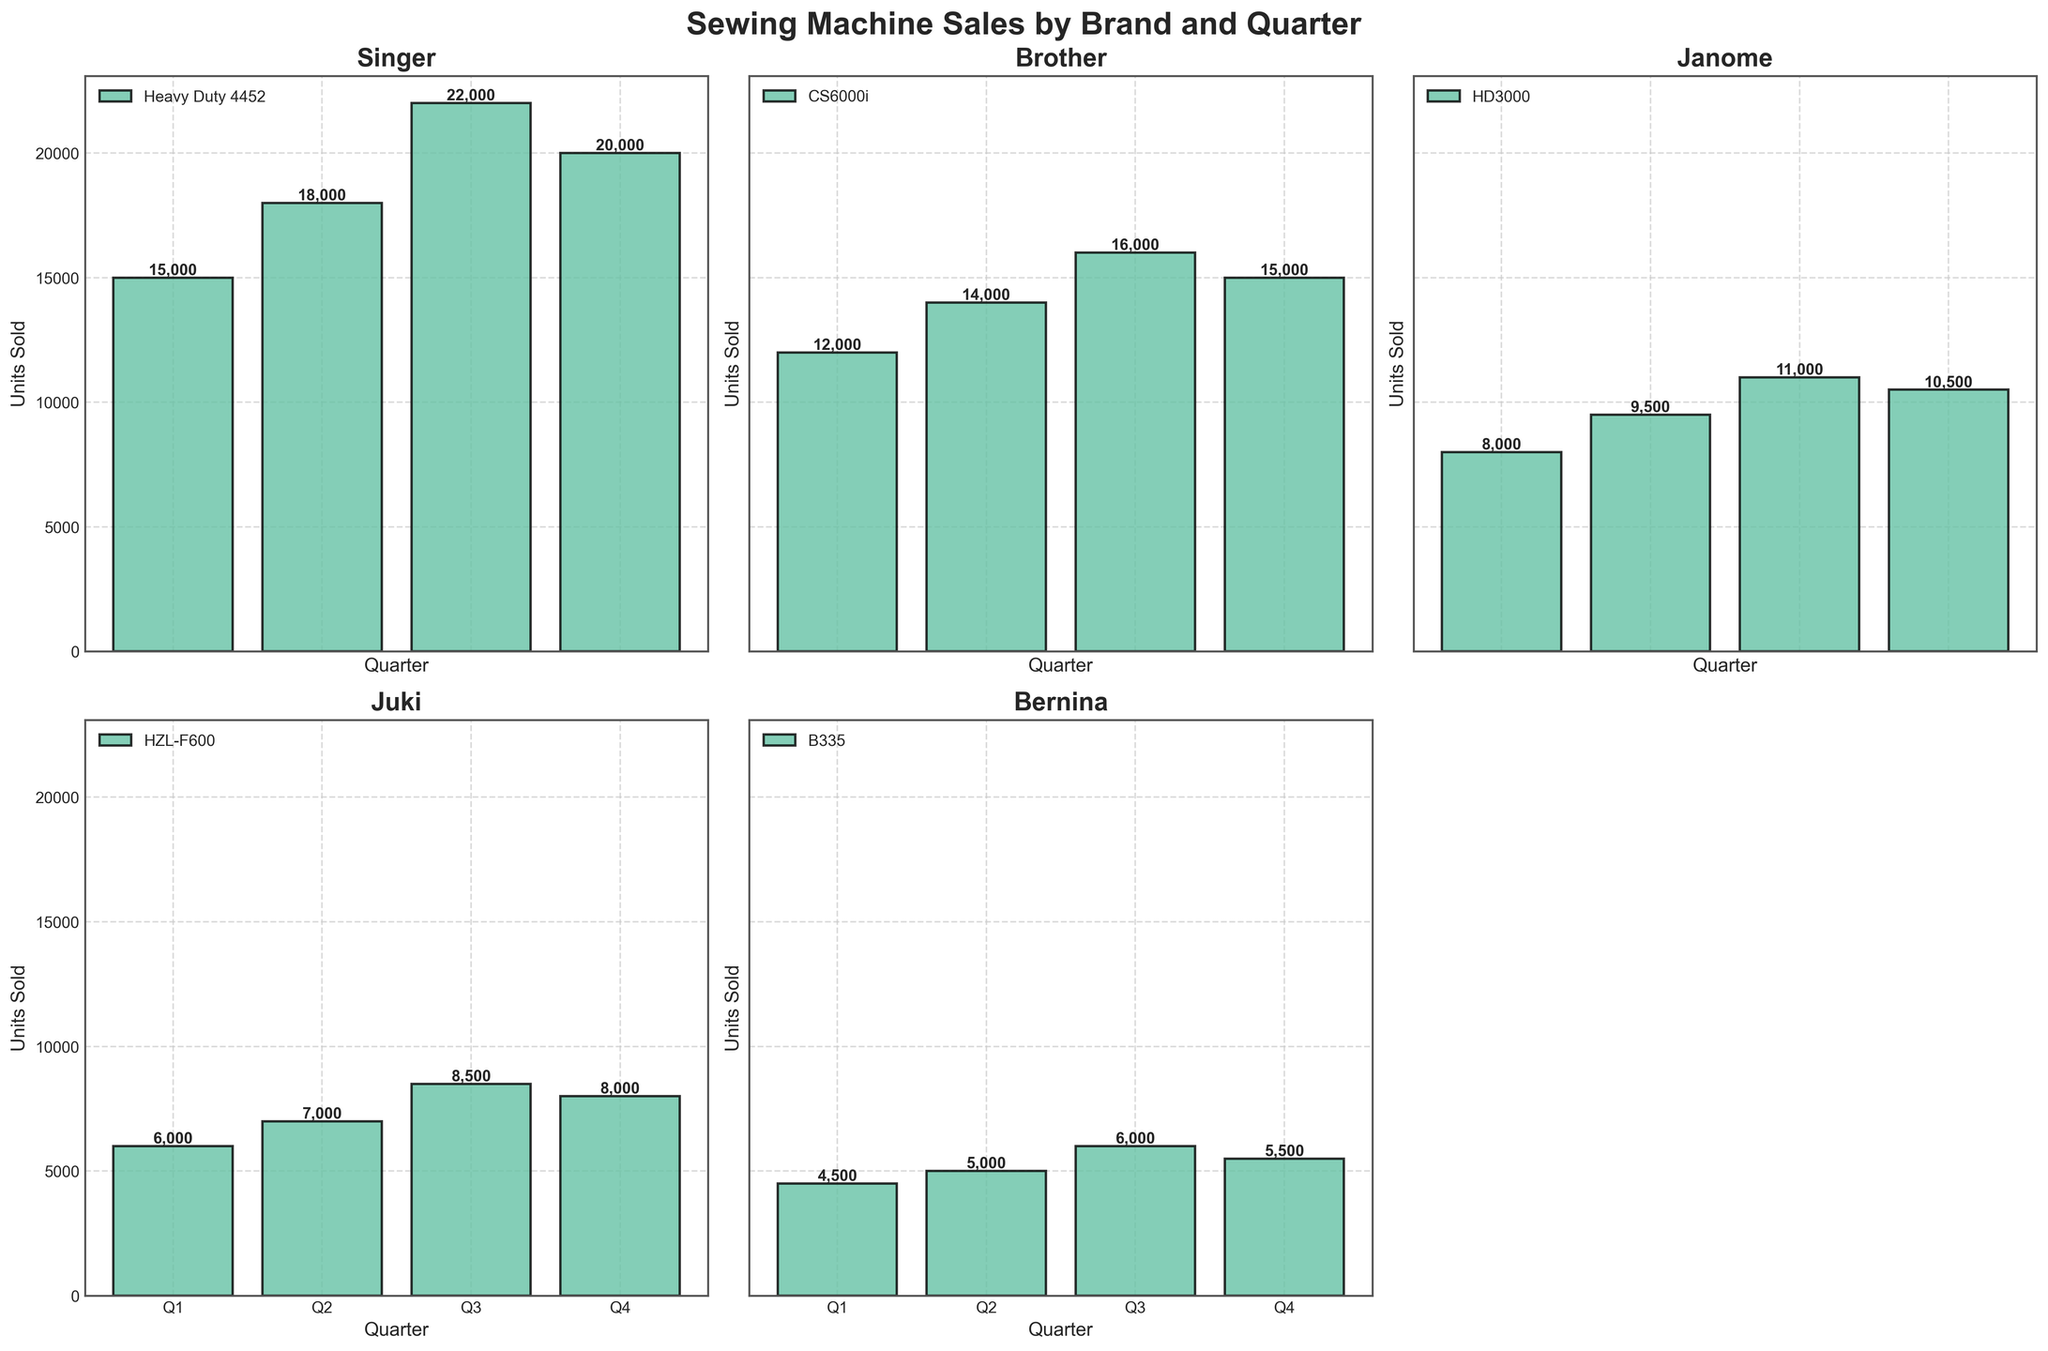What is the title of the figure? The title is usually placed at the top of the figure in bigger and bold text. In this figure, the title reads "Sewing Machine Sales by Brand and Quarter".
Answer: Sewing Machine Sales by Brand and Quarter Which brand has the highest total units sold in Q3? To find the highest total units sold in Q3, sum up the units sold for each model within each brand and compare. Singer has a total of 22,000 units sold in Q3, which is higher than other brands.
Answer: Singer How many brands are shown in the figure? The different subplots represent each brand. By counting the number of individual subplots, we can determine there are 5 brands shown.
Answer: 5 What are the units sold for the Brother brand in Q4? Locate the Brother subplot and look at the height of the bar for Q4. The label shows that 15,000 units were sold.
Answer: 15,000 Which model of Janome had higher units sold in Q2 compared to Q1? Within the Janome subplot, compare the heights (or numerical labels) of the units sold for each of its models between Q1 and Q2. The HD3000 model sold 9,500 units in Q2 compared to 8,000 units in Q1.
Answer: HD3000 What is the difference in units sold between Q4 and Q2 for the Bernina brand? First, find the units sold in Q4 (5,500 units) and Q2 (5,000 units) for Bernina from its subplot. Calculate the difference, which is 5,500 - 5,000 = 500 units.
Answer: 500 units Which quarter had the highest total sales across all brands? Sum the units sold for all brands in each quarter and compare totals. Summing up from each subplot, Q3 has the highest total.
Answer: Q3 Which brand has the smallest variance in units sold across quarters? To determine variance, look at each subplot and notice the consistency in bar heights for each quarter. Bernina shows minimal variance as its bars are approximately even across all quarters.
Answer: Bernina 